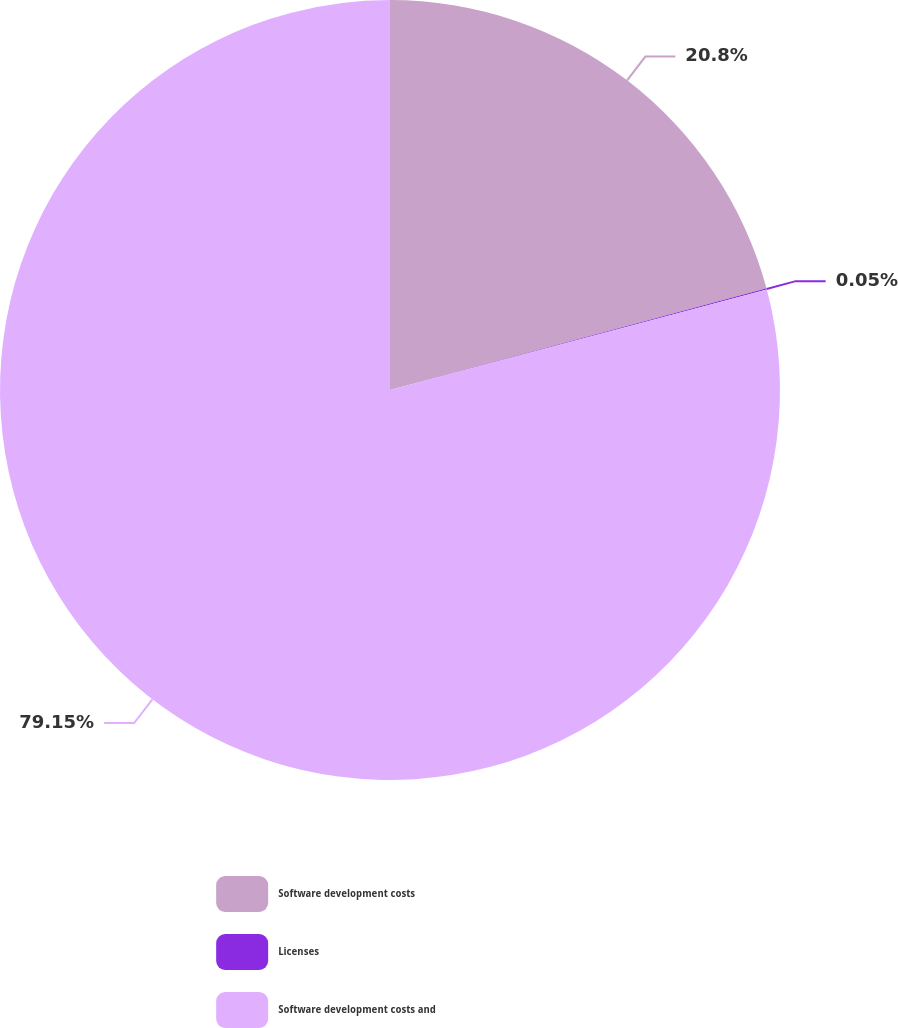<chart> <loc_0><loc_0><loc_500><loc_500><pie_chart><fcel>Software development costs<fcel>Licenses<fcel>Software development costs and<nl><fcel>20.8%<fcel>0.05%<fcel>79.14%<nl></chart> 